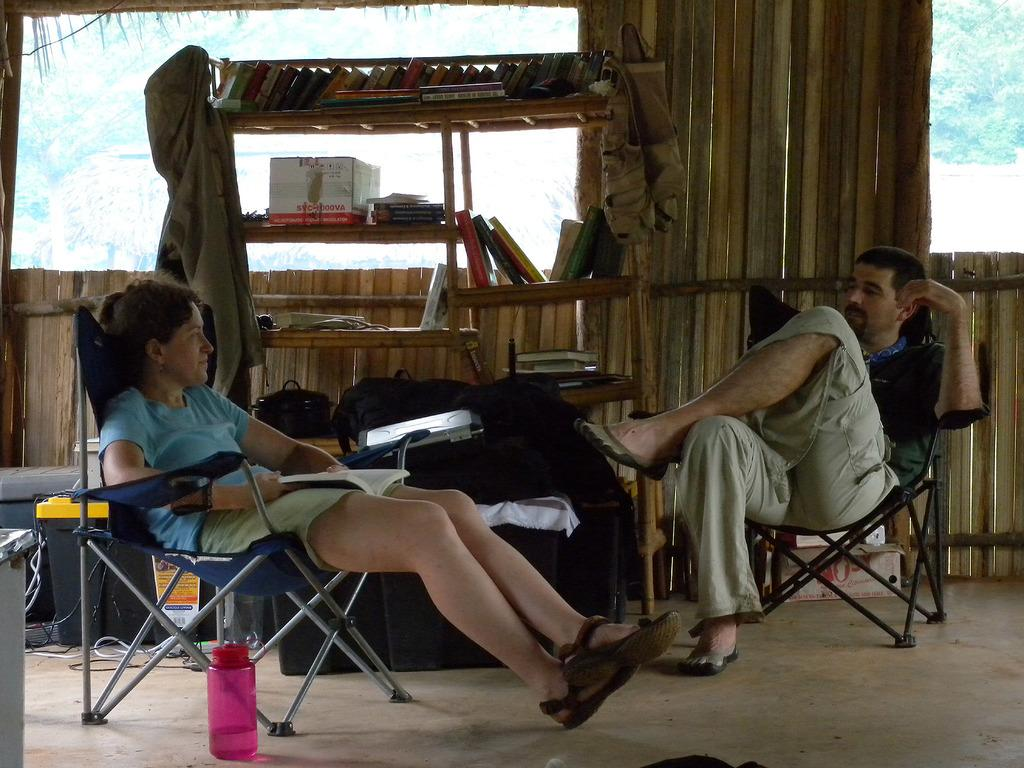Who are the people in the image? There is a woman and a man in the image. What are the woman and man doing in the image? Both the woman and man are sitting on a chair. What is located at the bottom of the image? There is a bottle at the bottom of the image. What can be seen in the middle of the image? There are shelves in the middle of the image. What is on the shelves? There are books on the shelves. What type of memory is being stored in the books on the shelves? The image does not provide information about the content of the books, so it is not possible to determine the type of memory being stored in them. 